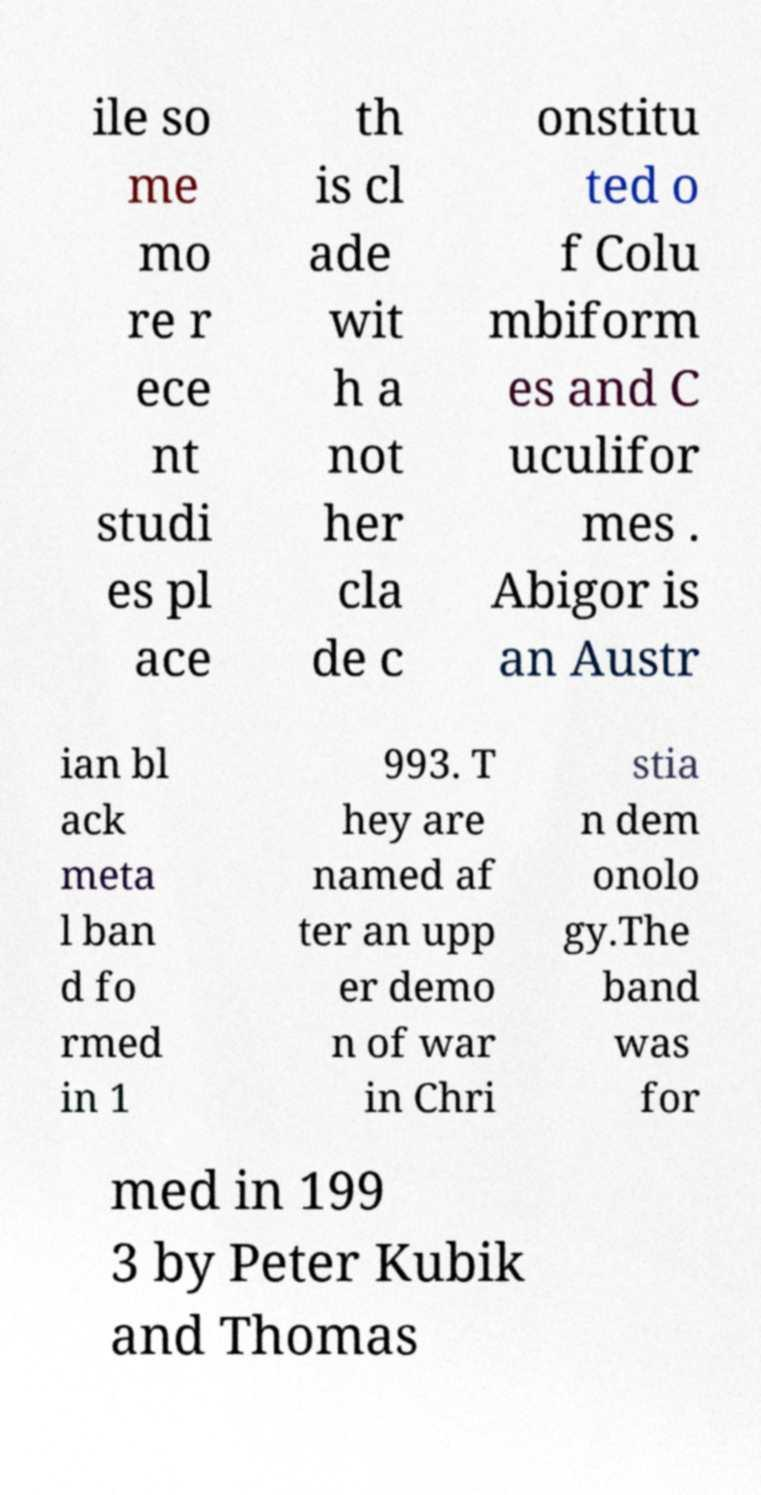There's text embedded in this image that I need extracted. Can you transcribe it verbatim? ile so me mo re r ece nt studi es pl ace th is cl ade wit h a not her cla de c onstitu ted o f Colu mbiform es and C uculifor mes . Abigor is an Austr ian bl ack meta l ban d fo rmed in 1 993. T hey are named af ter an upp er demo n of war in Chri stia n dem onolo gy.The band was for med in 199 3 by Peter Kubik and Thomas 